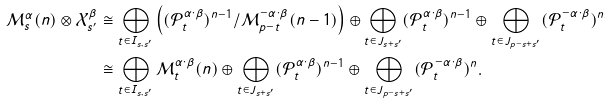<formula> <loc_0><loc_0><loc_500><loc_500>\mathcal { M } _ { s } ^ { \alpha } ( n ) \otimes \mathcal { X } _ { s ^ { \prime } } ^ { \beta } & \cong \bigoplus _ { t \in I _ { s , s ^ { \prime } } } \left ( ( \mathcal { P } _ { t } ^ { \alpha \cdot \beta } ) ^ { n - 1 } / \mathcal { M } _ { p - t } ^ { - \alpha \cdot \beta } ( n - 1 ) \right ) \oplus \bigoplus _ { t \in J _ { s + s ^ { \prime } } } ( \mathcal { P } _ { t } ^ { \alpha \cdot \beta } ) ^ { n - 1 } \oplus \bigoplus _ { t \in J _ { p - s + s ^ { \prime } } } ( \mathcal { P } _ { t } ^ { - \alpha \cdot \beta } ) ^ { n } \\ & \cong \bigoplus _ { t \in I _ { s , s ^ { \prime } } } \mathcal { M } _ { t } ^ { \alpha \cdot \beta } ( n ) \oplus \bigoplus _ { t \in J _ { s + s ^ { \prime } } } ( \mathcal { P } _ { t } ^ { \alpha \cdot \beta } ) ^ { n - 1 } \oplus \bigoplus _ { t \in J _ { p - s + s ^ { \prime } } } ( \mathcal { P } _ { t } ^ { - \alpha \cdot \beta } ) ^ { n } .</formula> 